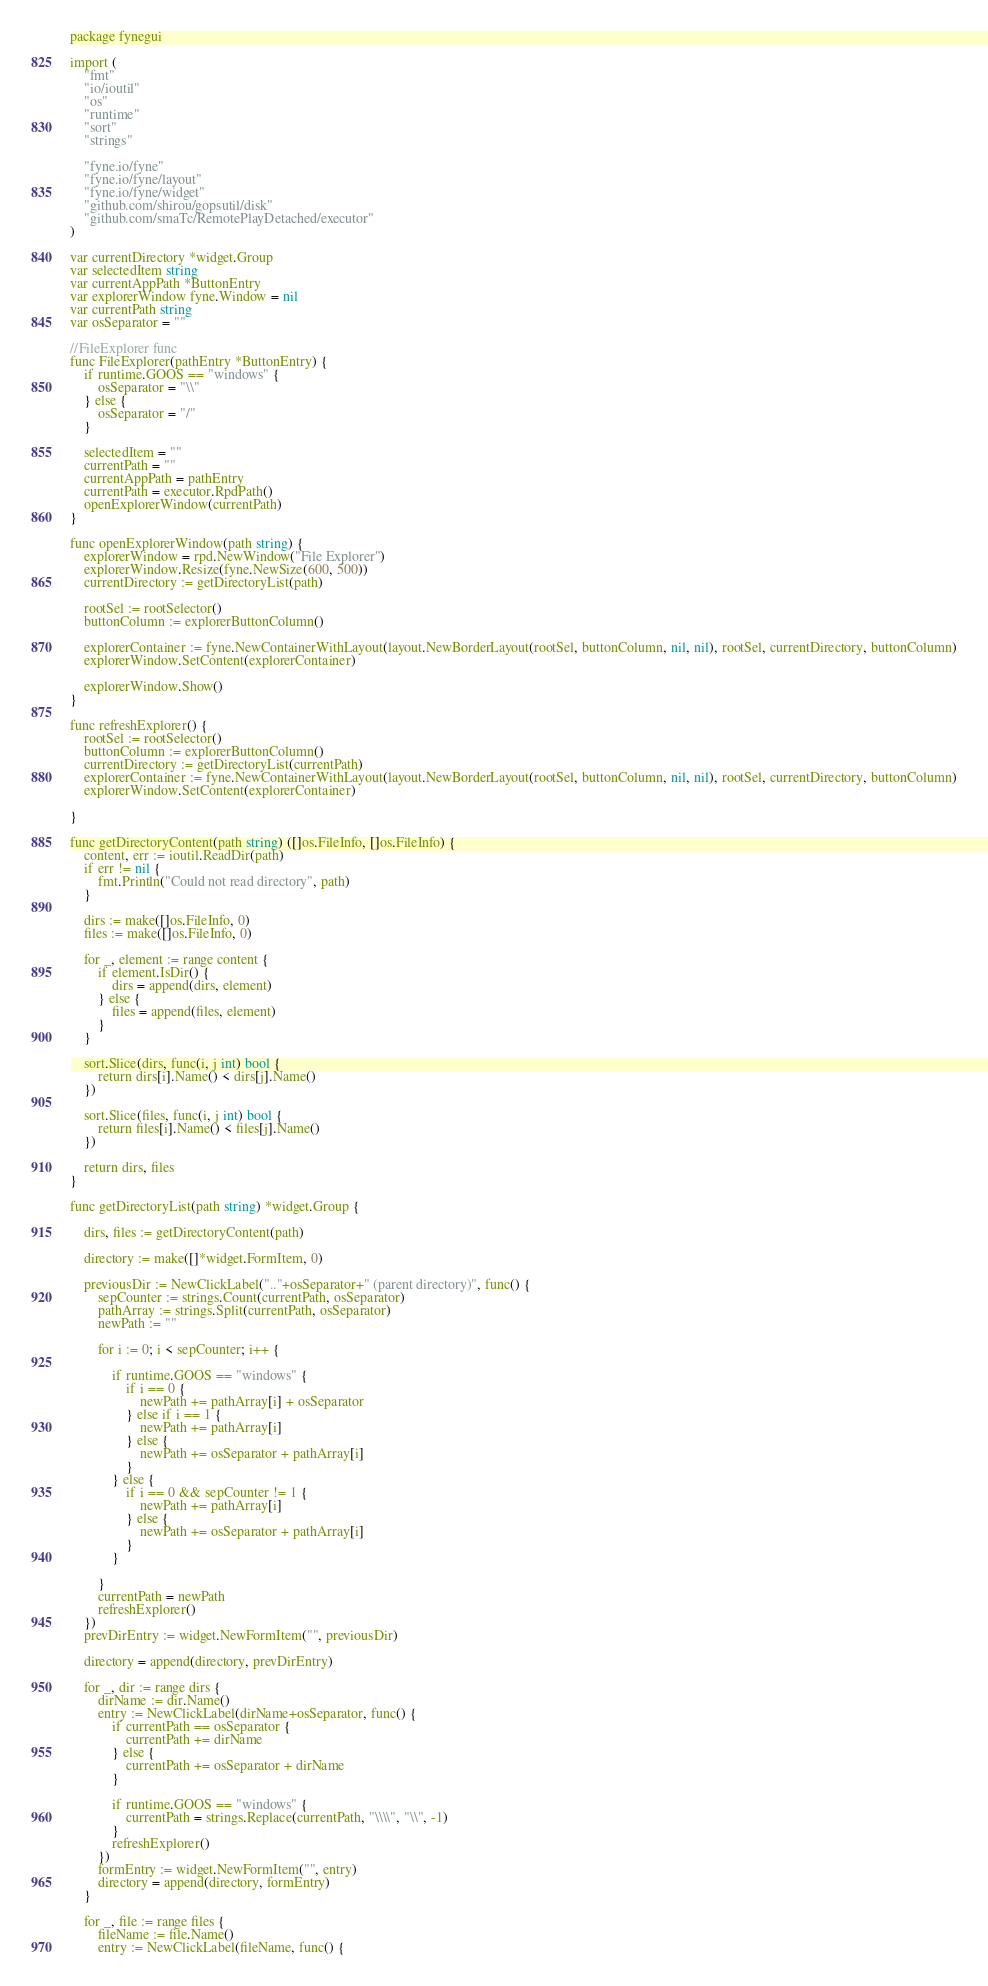<code> <loc_0><loc_0><loc_500><loc_500><_Go_>package fynegui

import (
	"fmt"
	"io/ioutil"
	"os"
	"runtime"
	"sort"
	"strings"

	"fyne.io/fyne"
	"fyne.io/fyne/layout"
	"fyne.io/fyne/widget"
	"github.com/shirou/gopsutil/disk"
	"github.com/smaTc/RemotePlayDetached/executor"
)

var currentDirectory *widget.Group
var selectedItem string
var currentAppPath *ButtonEntry
var explorerWindow fyne.Window = nil
var currentPath string
var osSeparator = ""

//FileExplorer func
func FileExplorer(pathEntry *ButtonEntry) {
	if runtime.GOOS == "windows" {
		osSeparator = "\\"
	} else {
		osSeparator = "/"
	}

	selectedItem = ""
	currentPath = ""
	currentAppPath = pathEntry
	currentPath = executor.RpdPath()
	openExplorerWindow(currentPath)
}

func openExplorerWindow(path string) {
	explorerWindow = rpd.NewWindow("File Explorer")
	explorerWindow.Resize(fyne.NewSize(600, 500))
	currentDirectory := getDirectoryList(path)

	rootSel := rootSelector()
	buttonColumn := explorerButtonColumn()

	explorerContainer := fyne.NewContainerWithLayout(layout.NewBorderLayout(rootSel, buttonColumn, nil, nil), rootSel, currentDirectory, buttonColumn)
	explorerWindow.SetContent(explorerContainer)

	explorerWindow.Show()
}

func refreshExplorer() {
	rootSel := rootSelector()
	buttonColumn := explorerButtonColumn()
	currentDirectory := getDirectoryList(currentPath)
	explorerContainer := fyne.NewContainerWithLayout(layout.NewBorderLayout(rootSel, buttonColumn, nil, nil), rootSel, currentDirectory, buttonColumn)
	explorerWindow.SetContent(explorerContainer)

}

func getDirectoryContent(path string) ([]os.FileInfo, []os.FileInfo) {
	content, err := ioutil.ReadDir(path)
	if err != nil {
		fmt.Println("Could not read directory", path)
	}

	dirs := make([]os.FileInfo, 0)
	files := make([]os.FileInfo, 0)

	for _, element := range content {
		if element.IsDir() {
			dirs = append(dirs, element)
		} else {
			files = append(files, element)
		}
	}

	sort.Slice(dirs, func(i, j int) bool {
		return dirs[i].Name() < dirs[j].Name()
	})

	sort.Slice(files, func(i, j int) bool {
		return files[i].Name() < files[j].Name()
	})

	return dirs, files
}

func getDirectoryList(path string) *widget.Group {

	dirs, files := getDirectoryContent(path)

	directory := make([]*widget.FormItem, 0)

	previousDir := NewClickLabel(".."+osSeparator+" (parent directory)", func() {
		sepCounter := strings.Count(currentPath, osSeparator)
		pathArray := strings.Split(currentPath, osSeparator)
		newPath := ""

		for i := 0; i < sepCounter; i++ {

			if runtime.GOOS == "windows" {
				if i == 0 {
					newPath += pathArray[i] + osSeparator
				} else if i == 1 {
					newPath += pathArray[i]
				} else {
					newPath += osSeparator + pathArray[i]
				}
			} else {
				if i == 0 && sepCounter != 1 {
					newPath += pathArray[i]
				} else {
					newPath += osSeparator + pathArray[i]
				}
			}

		}
		currentPath = newPath
		refreshExplorer()
	})
	prevDirEntry := widget.NewFormItem("", previousDir)

	directory = append(directory, prevDirEntry)

	for _, dir := range dirs {
		dirName := dir.Name()
		entry := NewClickLabel(dirName+osSeparator, func() {
			if currentPath == osSeparator {
				currentPath += dirName
			} else {
				currentPath += osSeparator + dirName
			}

			if runtime.GOOS == "windows" {
				currentPath = strings.Replace(currentPath, "\\\\", "\\", -1)
			}
			refreshExplorer()
		})
		formEntry := widget.NewFormItem("", entry)
		directory = append(directory, formEntry)
	}

	for _, file := range files {
		fileName := file.Name()
		entry := NewClickLabel(fileName, func() {</code> 